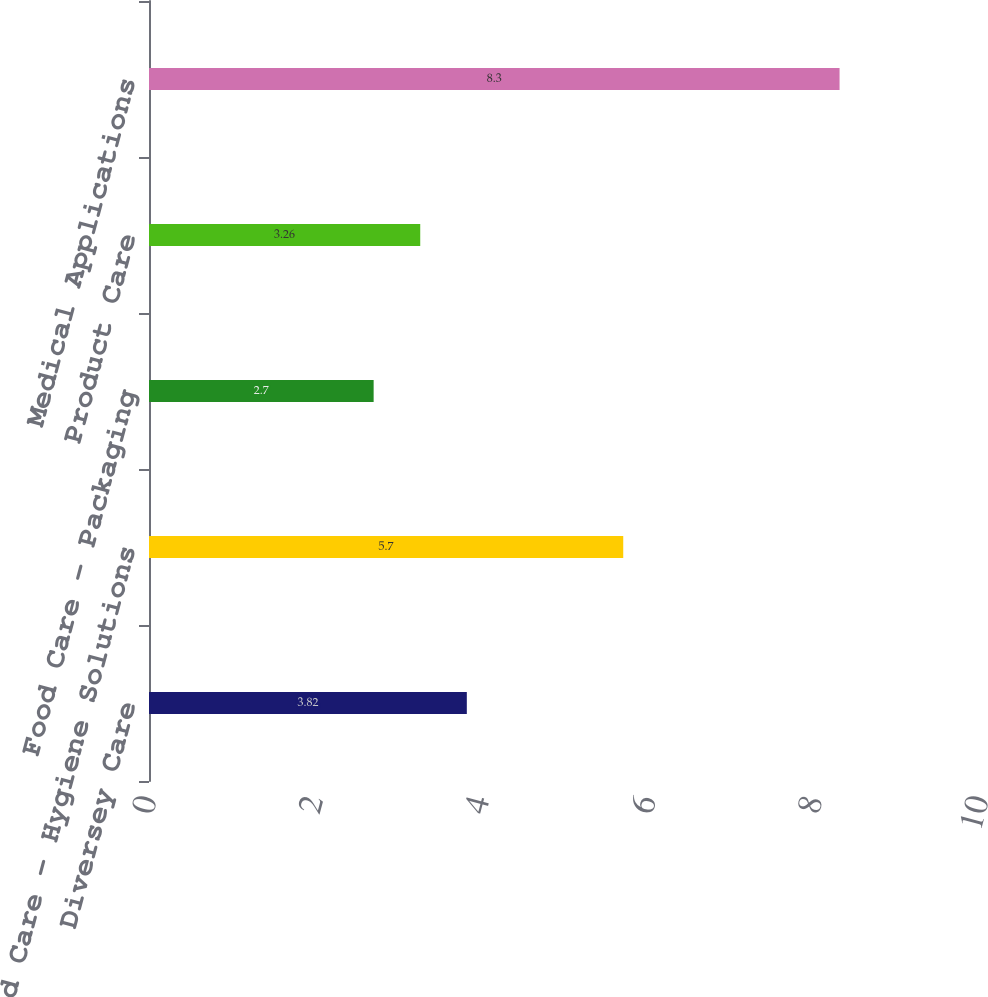Convert chart. <chart><loc_0><loc_0><loc_500><loc_500><bar_chart><fcel>Diversey Care<fcel>Food Care - Hygiene Solutions<fcel>Food Care - Packaging<fcel>Product Care<fcel>Medical Applications<nl><fcel>3.82<fcel>5.7<fcel>2.7<fcel>3.26<fcel>8.3<nl></chart> 